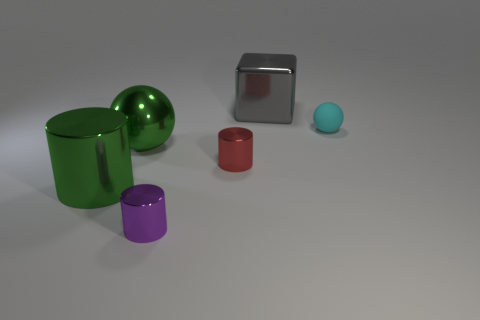Add 3 purple shiny cylinders. How many objects exist? 9 Subtract all spheres. How many objects are left? 4 Add 3 tiny red things. How many tiny red things are left? 4 Add 4 large green spheres. How many large green spheres exist? 5 Subtract 0 blue cylinders. How many objects are left? 6 Subtract all large gray cubes. Subtract all large green metal cylinders. How many objects are left? 4 